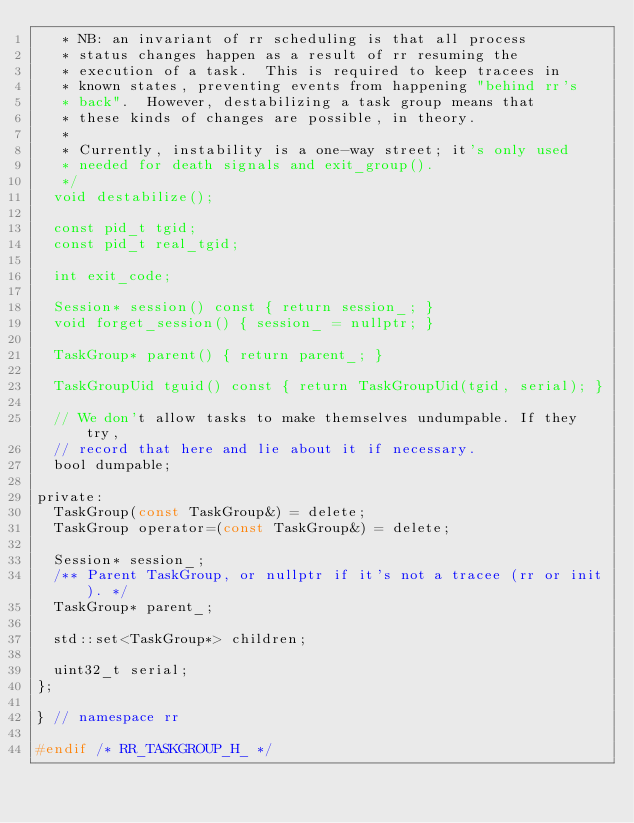<code> <loc_0><loc_0><loc_500><loc_500><_C_>   * NB: an invariant of rr scheduling is that all process
   * status changes happen as a result of rr resuming the
   * execution of a task.  This is required to keep tracees in
   * known states, preventing events from happening "behind rr's
   * back".  However, destabilizing a task group means that
   * these kinds of changes are possible, in theory.
   *
   * Currently, instability is a one-way street; it's only used
   * needed for death signals and exit_group().
   */
  void destabilize();

  const pid_t tgid;
  const pid_t real_tgid;

  int exit_code;

  Session* session() const { return session_; }
  void forget_session() { session_ = nullptr; }

  TaskGroup* parent() { return parent_; }

  TaskGroupUid tguid() const { return TaskGroupUid(tgid, serial); }

  // We don't allow tasks to make themselves undumpable. If they try,
  // record that here and lie about it if necessary.
  bool dumpable;

private:
  TaskGroup(const TaskGroup&) = delete;
  TaskGroup operator=(const TaskGroup&) = delete;

  Session* session_;
  /** Parent TaskGroup, or nullptr if it's not a tracee (rr or init). */
  TaskGroup* parent_;

  std::set<TaskGroup*> children;

  uint32_t serial;
};

} // namespace rr

#endif /* RR_TASKGROUP_H_ */
</code> 